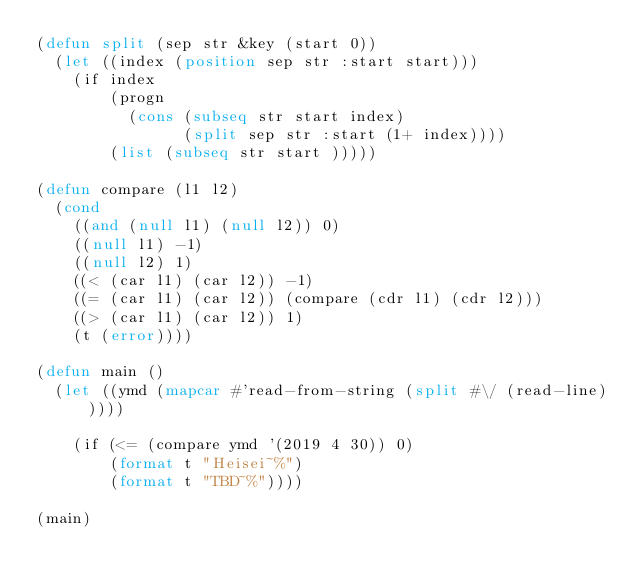<code> <loc_0><loc_0><loc_500><loc_500><_Lisp_>(defun split (sep str &key (start 0))
  (let ((index (position sep str :start start)))
    (if index
        (progn
          (cons (subseq str start index)
                (split sep str :start (1+ index))))
        (list (subseq str start )))))

(defun compare (l1 l2)
  (cond
    ((and (null l1) (null l2)) 0)
    ((null l1) -1)
    ((null l2) 1)
    ((< (car l1) (car l2)) -1)
    ((= (car l1) (car l2)) (compare (cdr l1) (cdr l2)))
    ((> (car l1) (car l2)) 1)
    (t (error))))

(defun main ()
  (let ((ymd (mapcar #'read-from-string (split #\/ (read-line)))))

    (if (<= (compare ymd '(2019 4 30)) 0)
        (format t "Heisei~%")
        (format t "TBD~%"))))

(main)</code> 